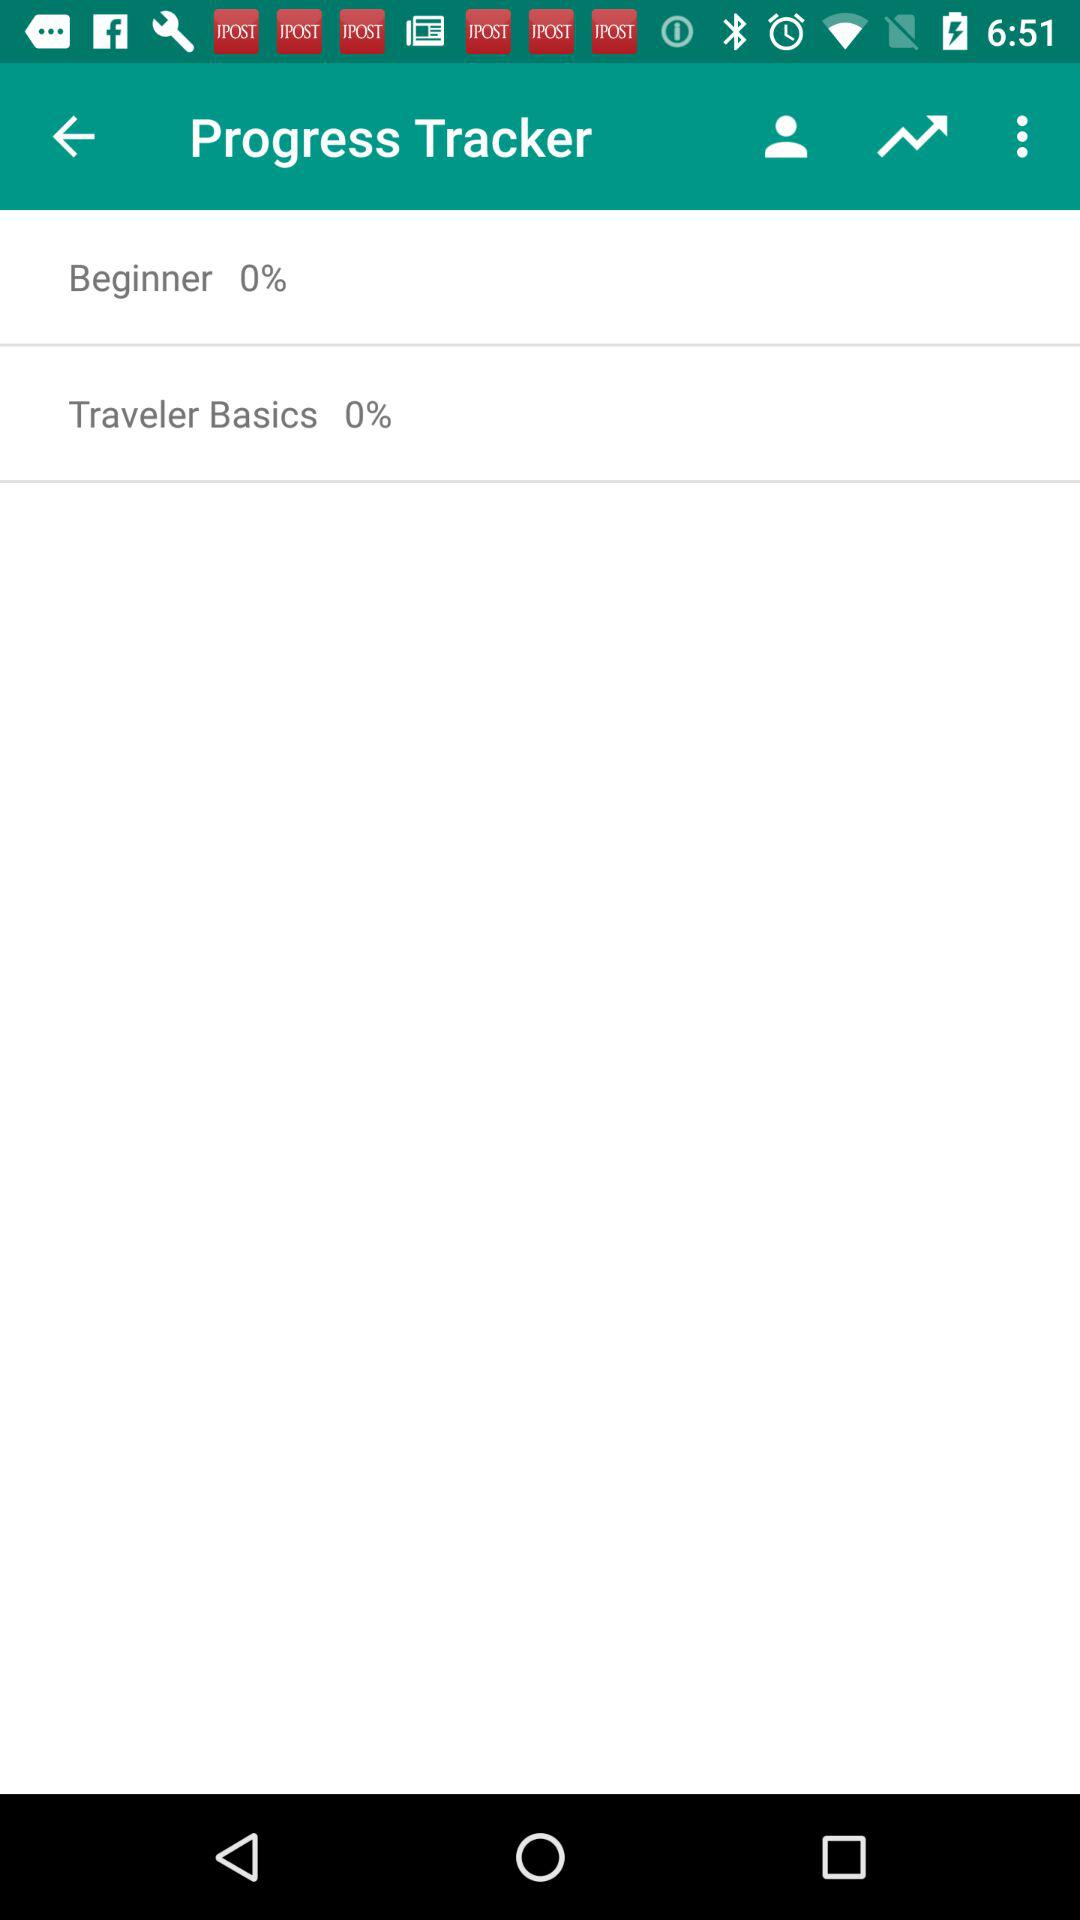What is the progress of "Traveler Basics"? The progress of "Traveler Basics" is 0%. 